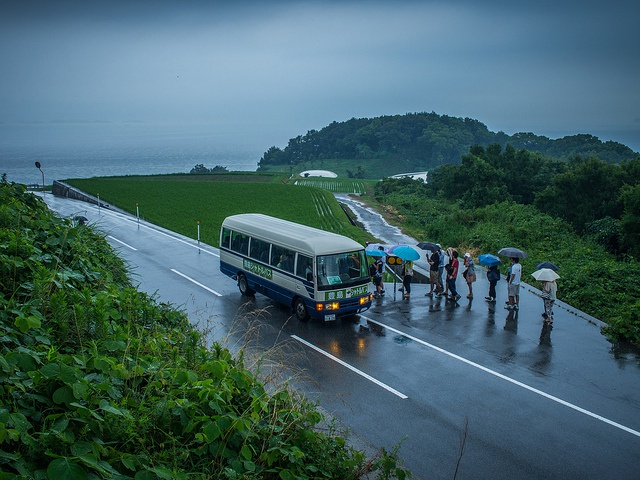Describe the objects in this image and their specific colors. I can see bus in darkblue, black, gray, and teal tones, people in darkblue, gray, and black tones, people in darkblue, black, gray, and blue tones, people in darkblue, gray, black, and blue tones, and people in darkblue, black, gray, and blue tones in this image. 